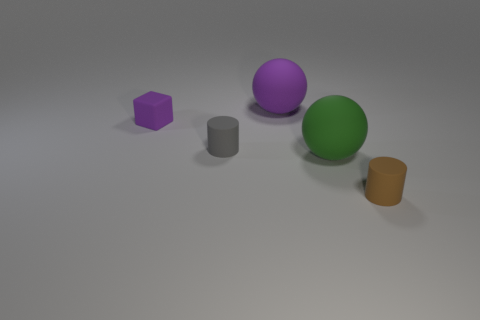Add 3 big green spheres. How many objects exist? 8 Subtract all cylinders. How many objects are left? 3 Add 5 tiny purple matte objects. How many tiny purple matte objects exist? 6 Subtract 0 gray balls. How many objects are left? 5 Subtract all small rubber cubes. Subtract all large balls. How many objects are left? 2 Add 1 purple matte spheres. How many purple matte spheres are left? 2 